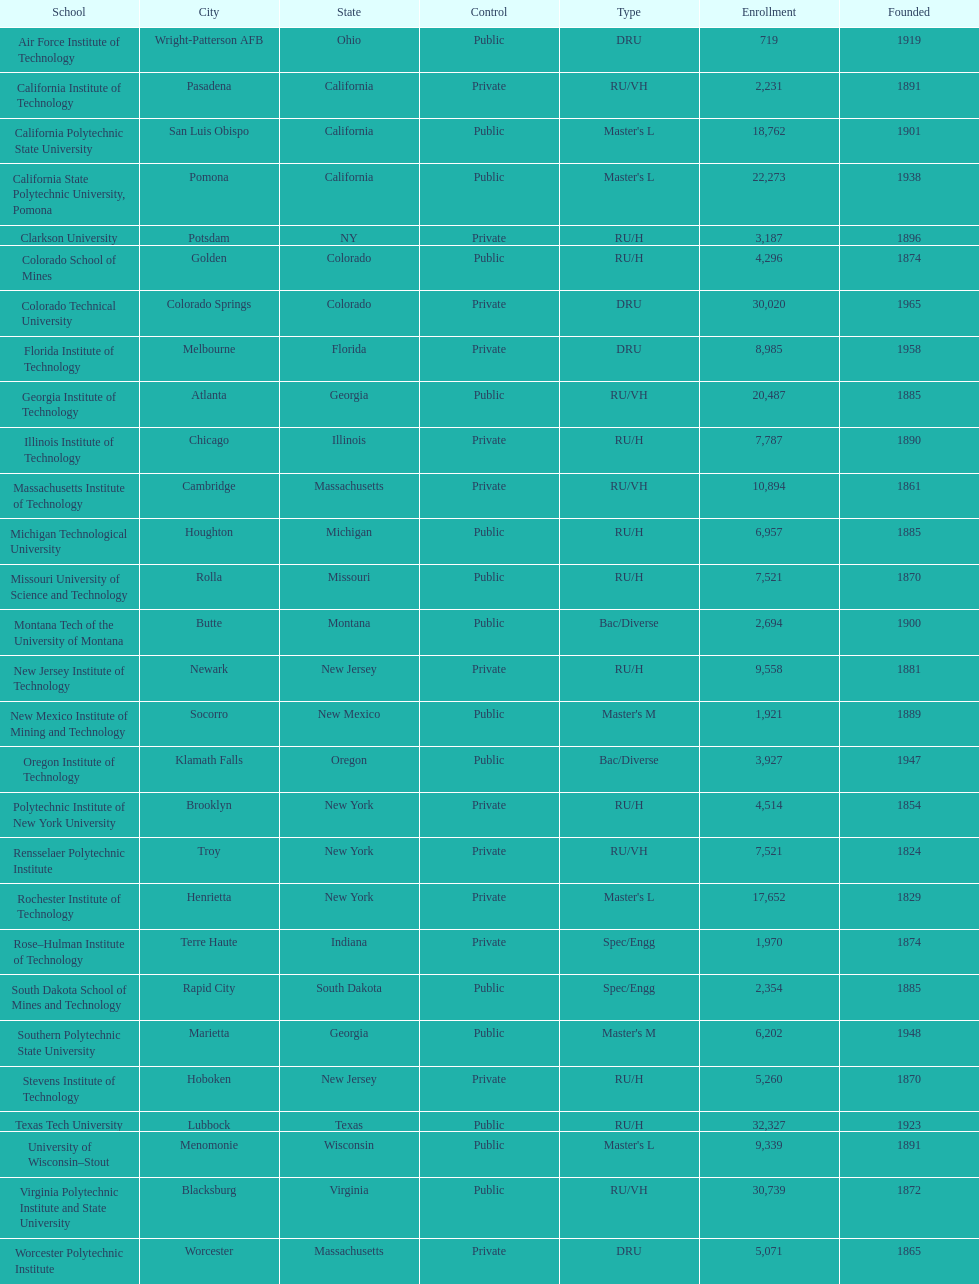What's the number of schools represented in the table? 28. 